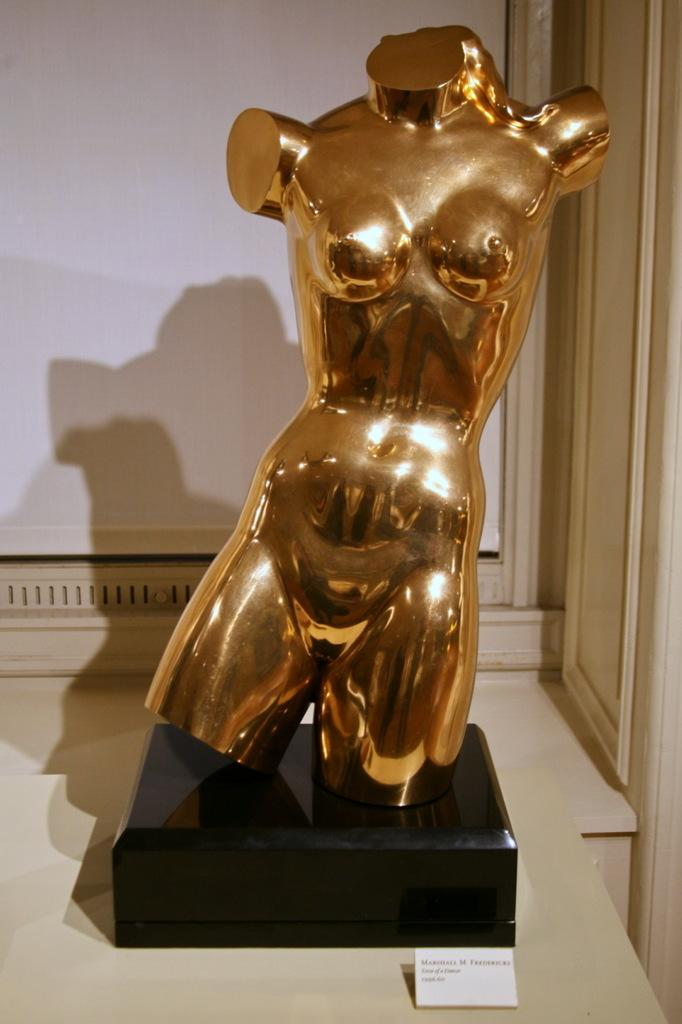What is the main subject of the image? There is a statue in the image. Is there any additional information provided about the statue? Yes, there is a descriptive note in front of the statue. What can be seen behind the statue? There is a wall behind the statue. How does the statue grip the stick in its hand? There is no stick present in the image, and the statue does not have hands to grip anything. 